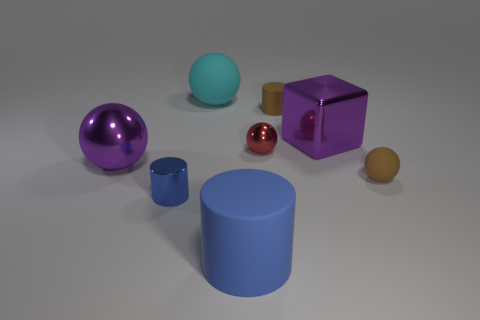Subtract 1 spheres. How many spheres are left? 3 Add 1 small red spheres. How many objects exist? 9 Subtract all cylinders. How many objects are left? 5 Subtract all red shiny objects. Subtract all tiny red balls. How many objects are left? 6 Add 6 metallic cylinders. How many metallic cylinders are left? 7 Add 2 cyan matte things. How many cyan matte things exist? 3 Subtract 0 green cubes. How many objects are left? 8 